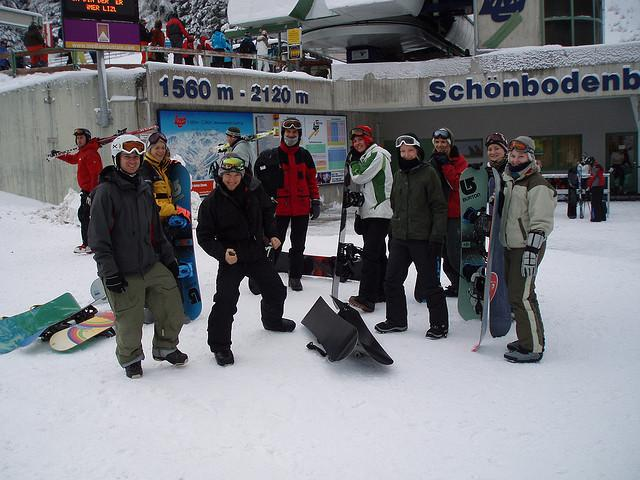This photo was taken in front of what kind of attraction?

Choices:
A) view point
B) restaurant
C) ski lodge
D) museum ski lodge 